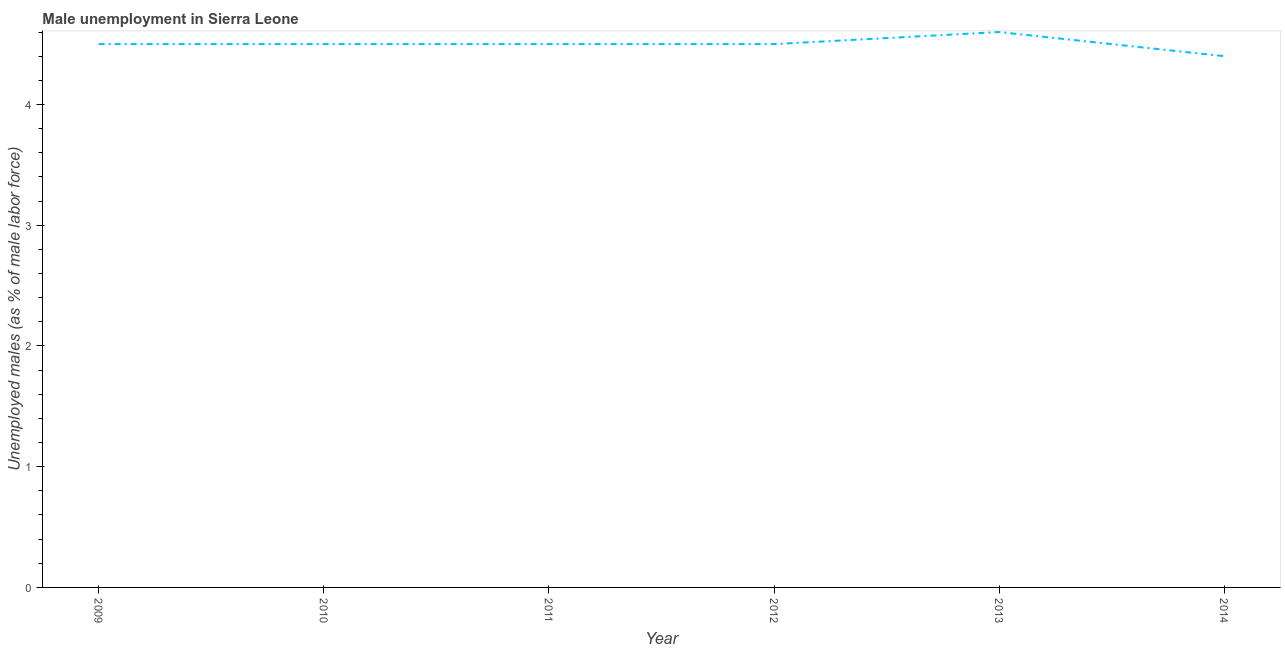What is the unemployed males population in 2010?
Your response must be concise. 4.5. Across all years, what is the maximum unemployed males population?
Give a very brief answer. 4.6. Across all years, what is the minimum unemployed males population?
Your answer should be very brief. 4.4. What is the sum of the unemployed males population?
Offer a very short reply. 27. What is the average unemployed males population per year?
Make the answer very short. 4.5. What is the median unemployed males population?
Give a very brief answer. 4.5. In how many years, is the unemployed males population greater than 2.4 %?
Make the answer very short. 6. What is the ratio of the unemployed males population in 2010 to that in 2011?
Ensure brevity in your answer.  1. What is the difference between the highest and the second highest unemployed males population?
Your answer should be compact. 0.1. Is the sum of the unemployed males population in 2013 and 2014 greater than the maximum unemployed males population across all years?
Make the answer very short. Yes. What is the difference between the highest and the lowest unemployed males population?
Provide a succinct answer. 0.2. In how many years, is the unemployed males population greater than the average unemployed males population taken over all years?
Provide a succinct answer. 1. How many years are there in the graph?
Provide a short and direct response. 6. What is the difference between two consecutive major ticks on the Y-axis?
Offer a terse response. 1. Are the values on the major ticks of Y-axis written in scientific E-notation?
Keep it short and to the point. No. Does the graph contain any zero values?
Your answer should be very brief. No. What is the title of the graph?
Your response must be concise. Male unemployment in Sierra Leone. What is the label or title of the X-axis?
Provide a succinct answer. Year. What is the label or title of the Y-axis?
Your answer should be compact. Unemployed males (as % of male labor force). What is the Unemployed males (as % of male labor force) of 2013?
Offer a terse response. 4.6. What is the Unemployed males (as % of male labor force) of 2014?
Offer a very short reply. 4.4. What is the difference between the Unemployed males (as % of male labor force) in 2009 and 2010?
Offer a very short reply. 0. What is the difference between the Unemployed males (as % of male labor force) in 2009 and 2014?
Provide a short and direct response. 0.1. What is the difference between the Unemployed males (as % of male labor force) in 2010 and 2011?
Provide a short and direct response. 0. What is the difference between the Unemployed males (as % of male labor force) in 2010 and 2012?
Provide a short and direct response. 0. What is the difference between the Unemployed males (as % of male labor force) in 2010 and 2013?
Give a very brief answer. -0.1. What is the difference between the Unemployed males (as % of male labor force) in 2010 and 2014?
Your response must be concise. 0.1. What is the difference between the Unemployed males (as % of male labor force) in 2011 and 2013?
Give a very brief answer. -0.1. What is the difference between the Unemployed males (as % of male labor force) in 2011 and 2014?
Provide a succinct answer. 0.1. What is the difference between the Unemployed males (as % of male labor force) in 2012 and 2013?
Your answer should be compact. -0.1. What is the ratio of the Unemployed males (as % of male labor force) in 2009 to that in 2014?
Provide a succinct answer. 1.02. What is the ratio of the Unemployed males (as % of male labor force) in 2010 to that in 2011?
Offer a very short reply. 1. What is the ratio of the Unemployed males (as % of male labor force) in 2012 to that in 2014?
Give a very brief answer. 1.02. What is the ratio of the Unemployed males (as % of male labor force) in 2013 to that in 2014?
Offer a terse response. 1.04. 